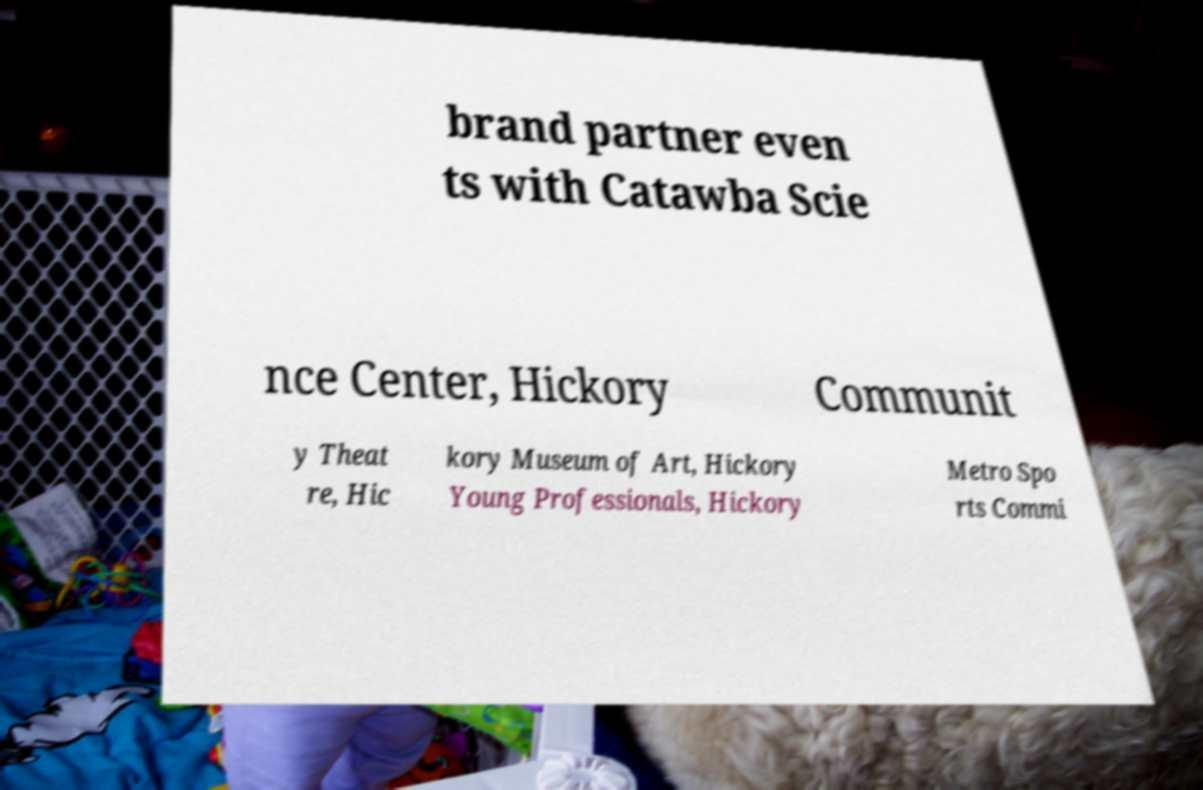What messages or text are displayed in this image? I need them in a readable, typed format. brand partner even ts with Catawba Scie nce Center, Hickory Communit y Theat re, Hic kory Museum of Art, Hickory Young Professionals, Hickory Metro Spo rts Commi 